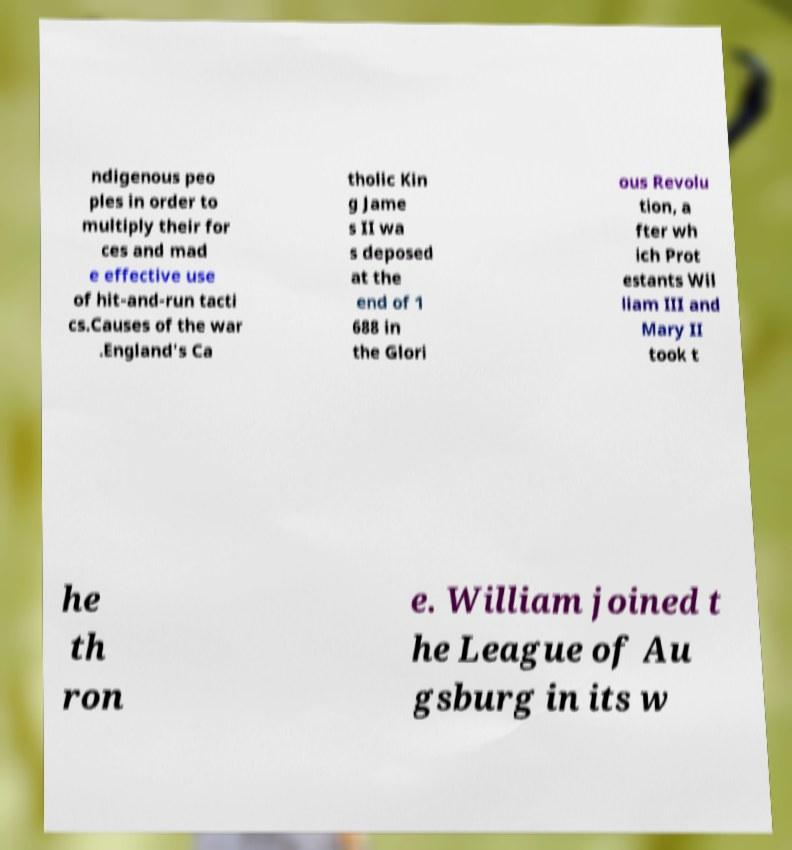Can you read and provide the text displayed in the image?This photo seems to have some interesting text. Can you extract and type it out for me? ndigenous peo ples in order to multiply their for ces and mad e effective use of hit-and-run tacti cs.Causes of the war .England's Ca tholic Kin g Jame s II wa s deposed at the end of 1 688 in the Glori ous Revolu tion, a fter wh ich Prot estants Wil liam III and Mary II took t he th ron e. William joined t he League of Au gsburg in its w 